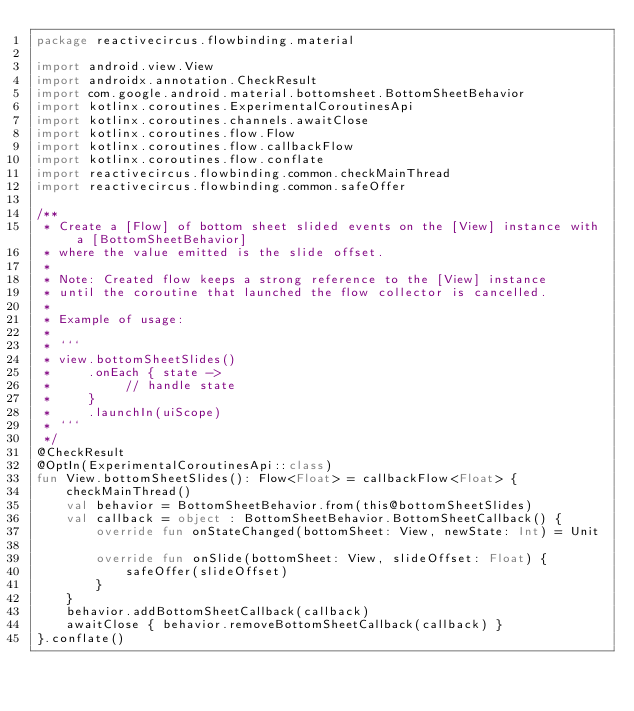<code> <loc_0><loc_0><loc_500><loc_500><_Kotlin_>package reactivecircus.flowbinding.material

import android.view.View
import androidx.annotation.CheckResult
import com.google.android.material.bottomsheet.BottomSheetBehavior
import kotlinx.coroutines.ExperimentalCoroutinesApi
import kotlinx.coroutines.channels.awaitClose
import kotlinx.coroutines.flow.Flow
import kotlinx.coroutines.flow.callbackFlow
import kotlinx.coroutines.flow.conflate
import reactivecircus.flowbinding.common.checkMainThread
import reactivecircus.flowbinding.common.safeOffer

/**
 * Create a [Flow] of bottom sheet slided events on the [View] instance with a [BottomSheetBehavior]
 * where the value emitted is the slide offset.
 *
 * Note: Created flow keeps a strong reference to the [View] instance
 * until the coroutine that launched the flow collector is cancelled.
 *
 * Example of usage:
 *
 * ```
 * view.bottomSheetSlides()
 *     .onEach { state ->
 *          // handle state
 *     }
 *     .launchIn(uiScope)
 * ```
 */
@CheckResult
@OptIn(ExperimentalCoroutinesApi::class)
fun View.bottomSheetSlides(): Flow<Float> = callbackFlow<Float> {
    checkMainThread()
    val behavior = BottomSheetBehavior.from(this@bottomSheetSlides)
    val callback = object : BottomSheetBehavior.BottomSheetCallback() {
        override fun onStateChanged(bottomSheet: View, newState: Int) = Unit

        override fun onSlide(bottomSheet: View, slideOffset: Float) {
            safeOffer(slideOffset)
        }
    }
    behavior.addBottomSheetCallback(callback)
    awaitClose { behavior.removeBottomSheetCallback(callback) }
}.conflate()
</code> 